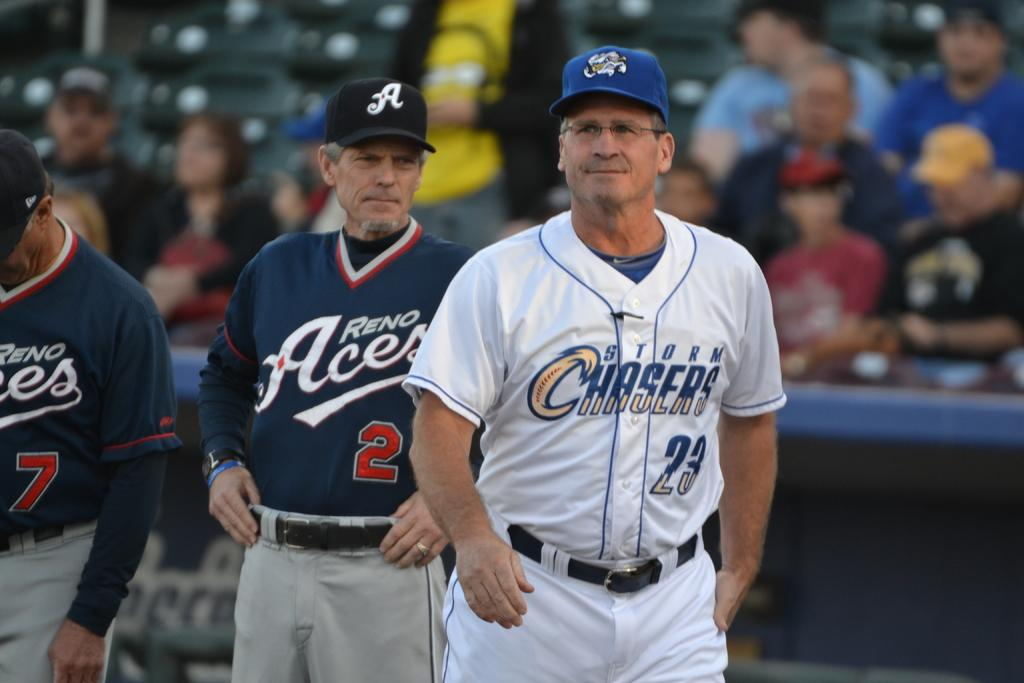<image>
Relay a brief, clear account of the picture shown. A man wearing a baseball uniform with Chasers on the jersey is waling in front of a dugout. 